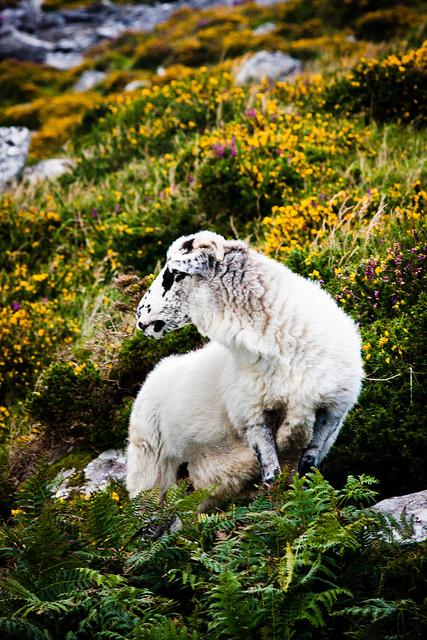How many legs does the animal have?
Concise answer only. 4. What kind of goat is this?
Concise answer only. Mountain. Is the goat on flat land?
Be succinct. No. 